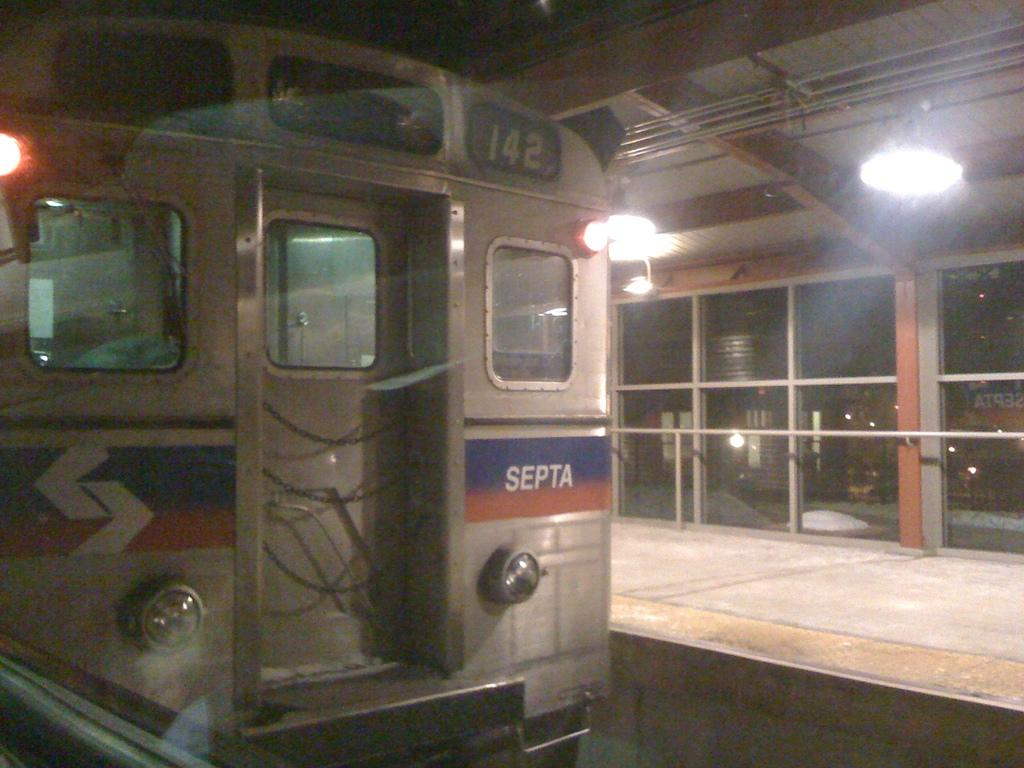What type of lighting feature is present in the image? There are headlights and lights in the image. What type of structure is visible in the image? There is a door and a platform in the image. What material is used for the windows in the image? The windows in the image are made of glass. How does the glass affect the visibility of the lights in the image? The glass allows for the visibility of lights through it. What type of crate is being used to transport the birthday cake in the image? There is no crate or birthday cake present in the image. 